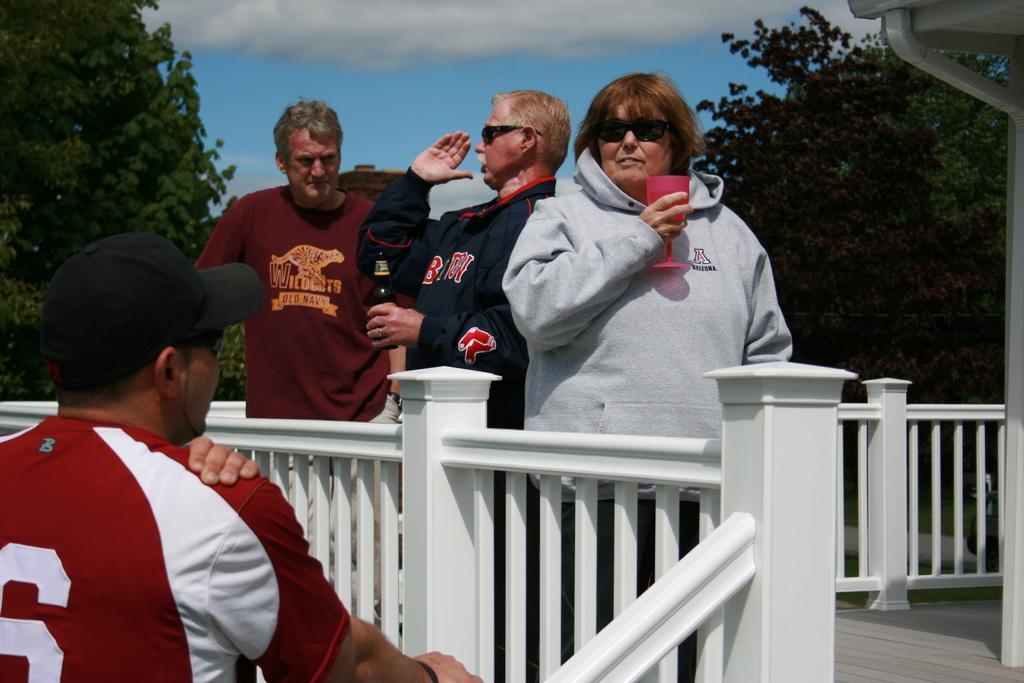Can you describe this image briefly? In the middle of the image few people are standing and holding something in their hands. Behind them there are some clouds and sky. Top right side of the image there are some trees. Bottom of the image there is fencing. Bottom left side of the image a man is standing and watching. Top left side of the image there is a tree. 